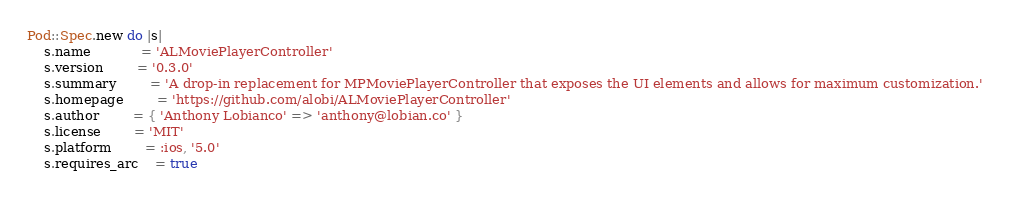<code> <loc_0><loc_0><loc_500><loc_500><_Ruby_>Pod::Spec.new do |s|
	s.name			= 'ALMoviePlayerController'
	s.version		= '0.3.0'
	s.summary		= 'A drop-in replacement for MPMoviePlayerController that exposes the UI elements and allows for maximum customization.'
	s.homepage		= 'https://github.com/alobi/ALMoviePlayerController'
	s.author		= { 'Anthony Lobianco' => 'anthony@lobian.co' }
	s.license 		= 'MIT'
	s.platform		= :ios, '5.0'
	s.requires_arc	= true</code> 